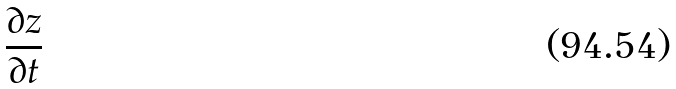<formula> <loc_0><loc_0><loc_500><loc_500>\frac { \partial z } { \partial t }</formula> 